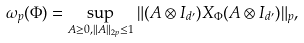<formula> <loc_0><loc_0><loc_500><loc_500>\omega _ { p } ( \Phi ) = \sup _ { A \geq 0 , \| A \| _ { 2 p } \leq 1 } \| ( A \otimes I _ { d ^ { \prime } } ) X _ { \Phi } ( A \otimes I _ { d ^ { \prime } } ) \| _ { p } ,</formula> 